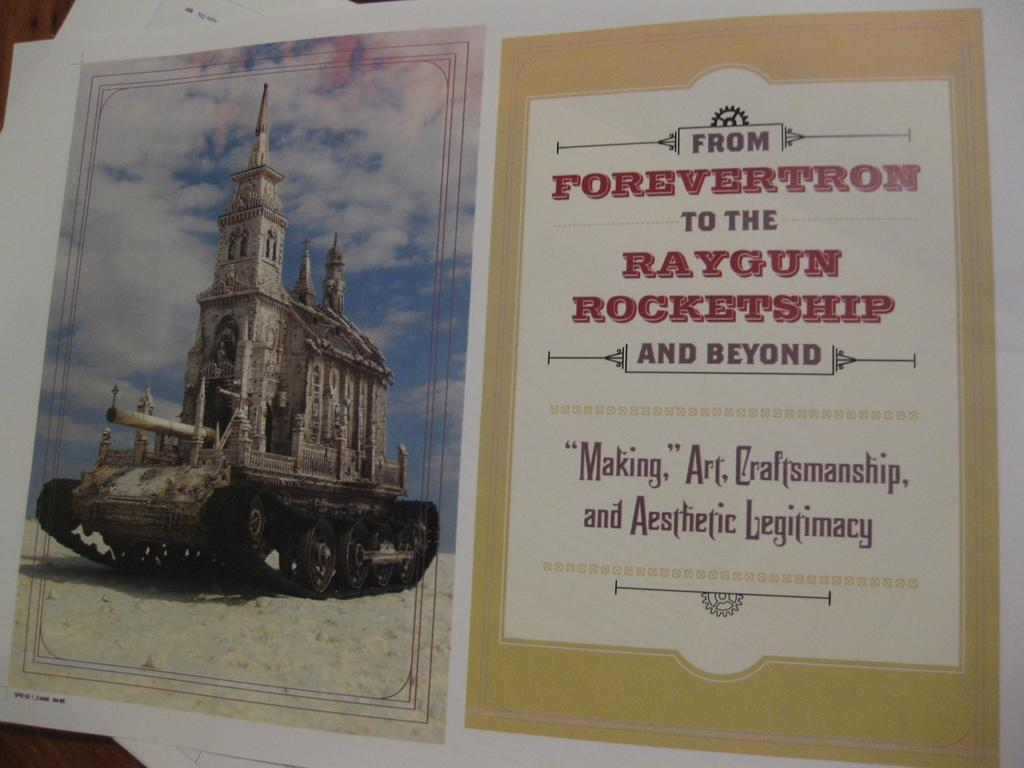<image>
Offer a succinct explanation of the picture presented. Book that says From Forevertron to the Raygun Rocketship and Beyond, shows an image of a tank. 